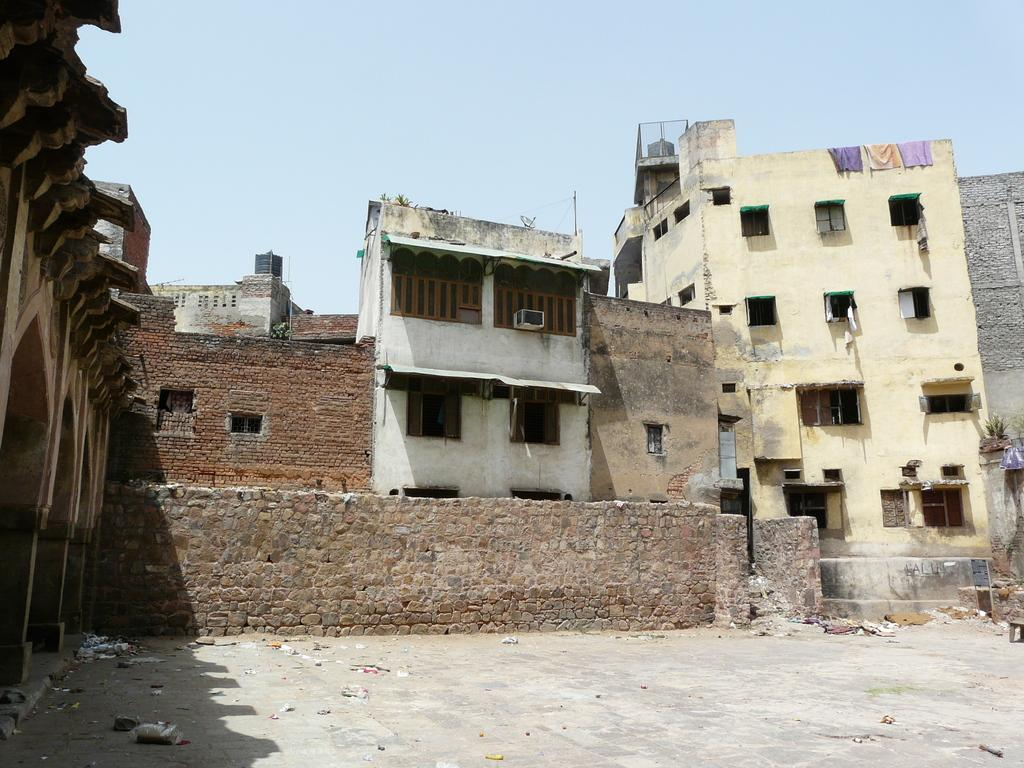What type of structures are present in the image? There are buildings in the image. What features can be seen on the buildings? The buildings have doors and windows. What is visible at the top of the image? The sky is visible at the top of the image. What type of memory is stored in the buildings in the image? There is no indication of memory storage in the buildings in the image. What color is the potato on the roof of the building? There is no potato present on the roof of the building in the image. 